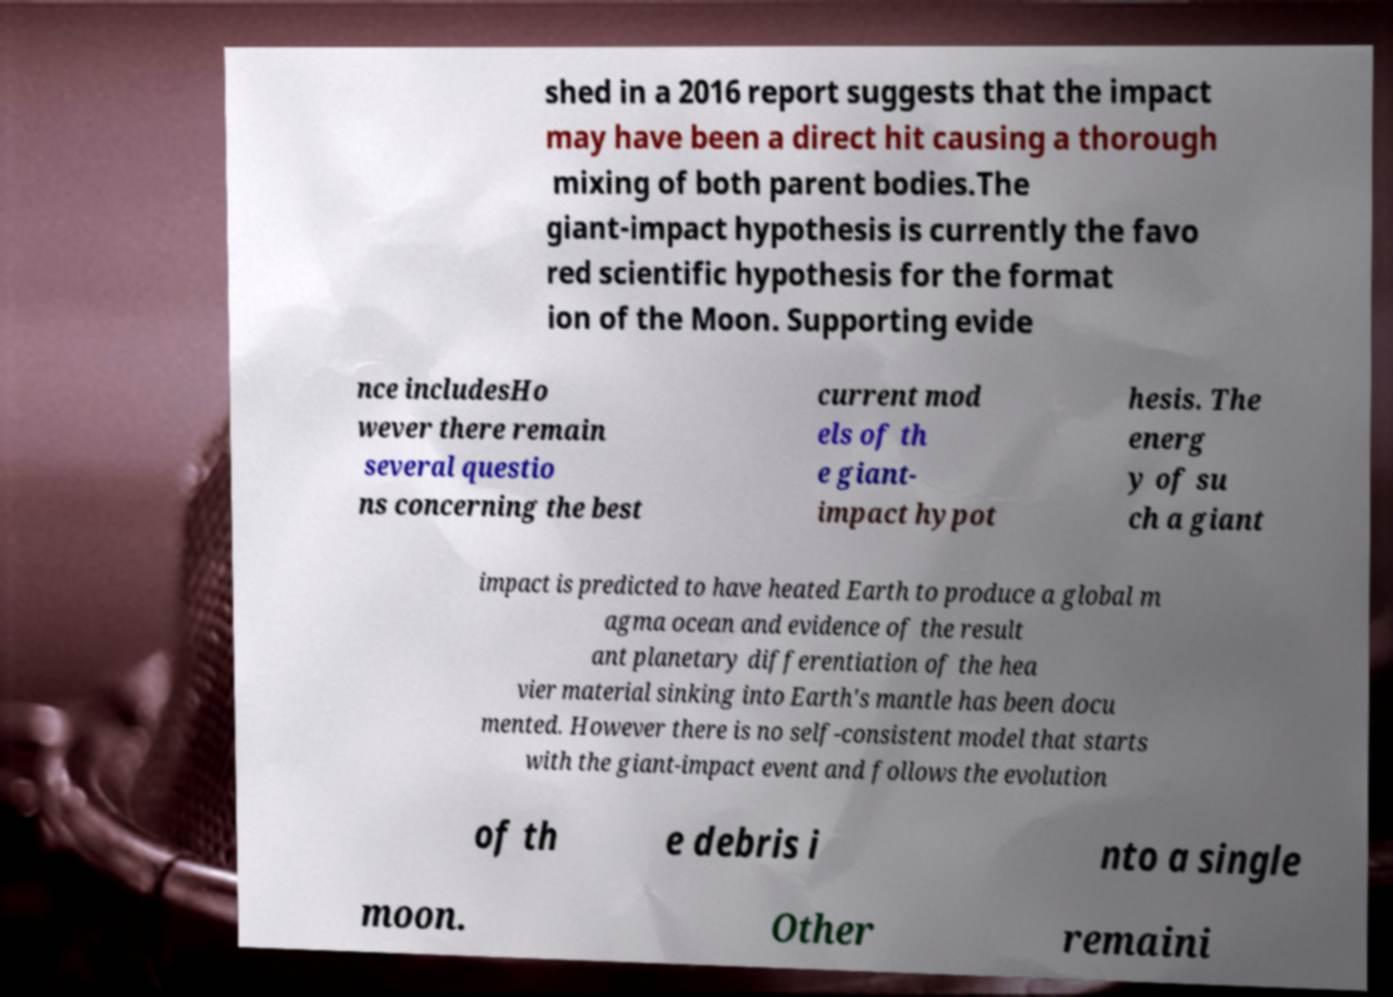Can you read and provide the text displayed in the image?This photo seems to have some interesting text. Can you extract and type it out for me? shed in a 2016 report suggests that the impact may have been a direct hit causing a thorough mixing of both parent bodies.The giant-impact hypothesis is currently the favo red scientific hypothesis for the format ion of the Moon. Supporting evide nce includesHo wever there remain several questio ns concerning the best current mod els of th e giant- impact hypot hesis. The energ y of su ch a giant impact is predicted to have heated Earth to produce a global m agma ocean and evidence of the result ant planetary differentiation of the hea vier material sinking into Earth's mantle has been docu mented. However there is no self-consistent model that starts with the giant-impact event and follows the evolution of th e debris i nto a single moon. Other remaini 